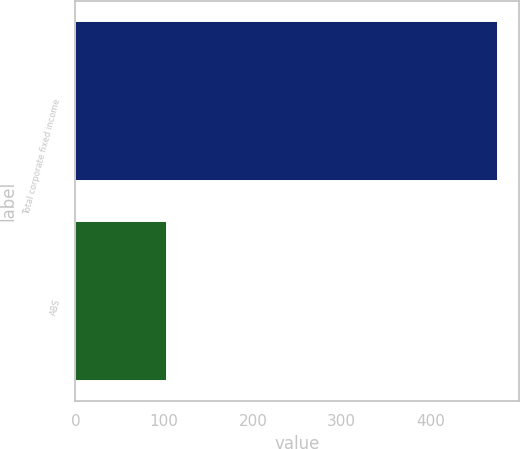Convert chart to OTSL. <chart><loc_0><loc_0><loc_500><loc_500><bar_chart><fcel>Total corporate fixed income<fcel>ABS<nl><fcel>476<fcel>103<nl></chart> 